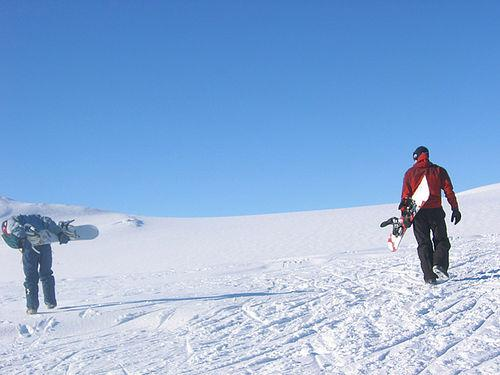In a single sentence, mention the colors of the snowboarders' outfits, the state of the sky, and the condition of the mountain. The snowboarders wear red and gray colors, the sky above is clear blue, and the mountain is blanketed in white snow with many ski tracks. Describe the key elements of the image focusing on the scenery and human figures. In a picturesque setting with clear blue skies and a snow-covered mountain, two snowboarders clad in vibrant jackets carry their snowboards as they walk upward. Combine the actions of the snowboarders, the appearance of the mountain, and the condition of the sky into one statement. Under a cloudless blue sky, two snowboarders in colorful gear make their way up a snow-covered mountain, carrying their boards and leaving tracks behind. Give a concise description of the snowy landscape and the movements of the main subjects in the image. Two snowboarders traverse a wintry landscape, navigating their way up a snow-laden mountain while carrying their snowboards with them. Using vivid detail, paint a picture of the main scene in the image with focus on the people. Two adventurous snowboarders, dressed in contrasting red and gray jackets, brave the snowy mountain, as they journey upward, gripping their vibrant snowboards. Write a brief synopsis of the scene, paying particular attention to the weather and the snow. On a sunny day with clear blue skies, two snowboarders traverse a snow-covered mountain, leaving a trail of tracks behind them. What are the two primary human figures in the image doing? The two main figures are snowboarders walking up a mountain, carrying their snowboards. Describe the appearance of the snowboarders and the mountain in a poetic manner. Beneath an expansive azure sky, two intrepid snowboarders clad in vibrant attire traverse a pristine, snow-laden mountainside, their boards in tow. Mention the most prominent activity involving the two people in the picture. Two people are walking up a snowy mountain, carrying snowboards on their way to snowboard. Provide a brief summary of the main objects and actions found in the image. Two snowboarders in colorful outfits walk up a snow-covered mountain, carrying snowboards and leaving tracks behind them, under a clear blue sky. 